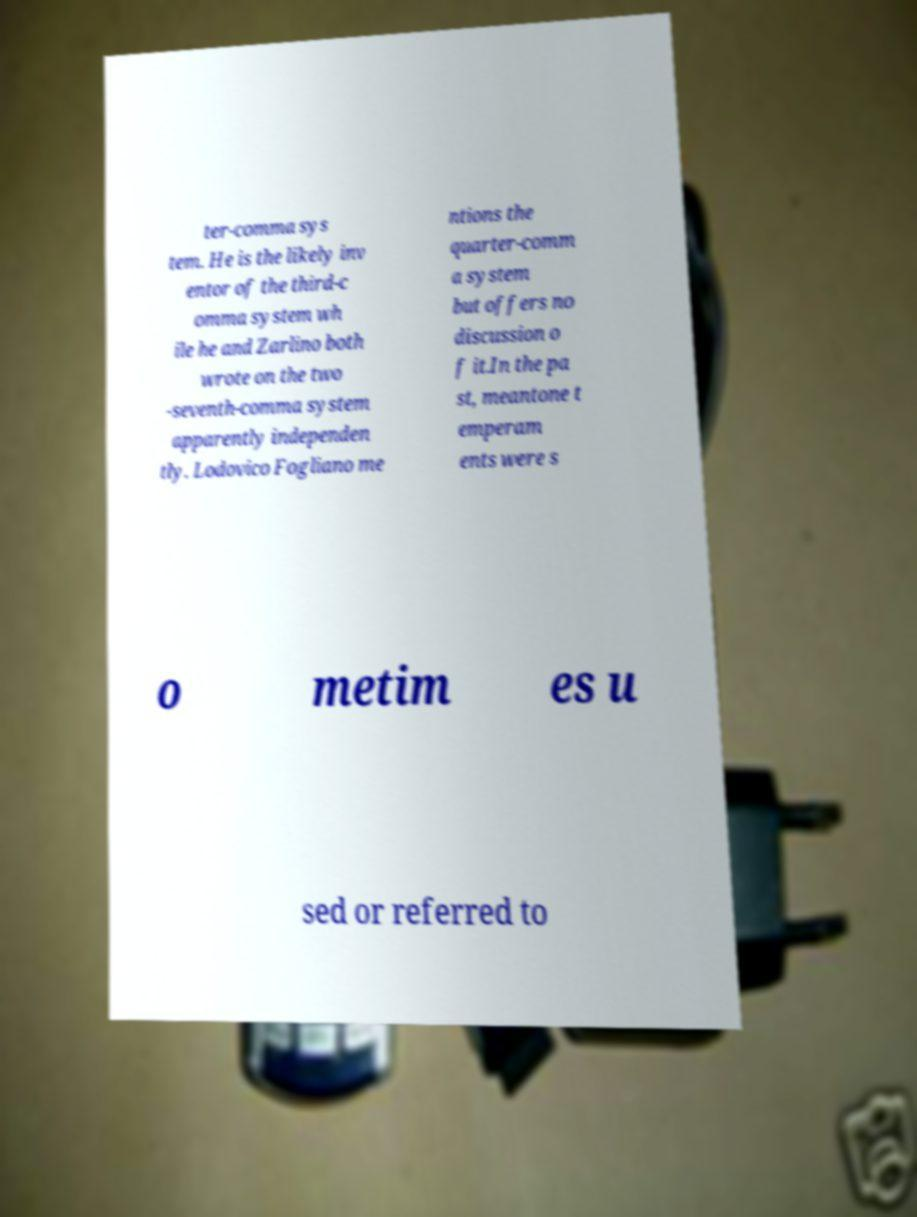Please identify and transcribe the text found in this image. ter-comma sys tem. He is the likely inv entor of the third-c omma system wh ile he and Zarlino both wrote on the two -seventh-comma system apparently independen tly. Lodovico Fogliano me ntions the quarter-comm a system but offers no discussion o f it.In the pa st, meantone t emperam ents were s o metim es u sed or referred to 